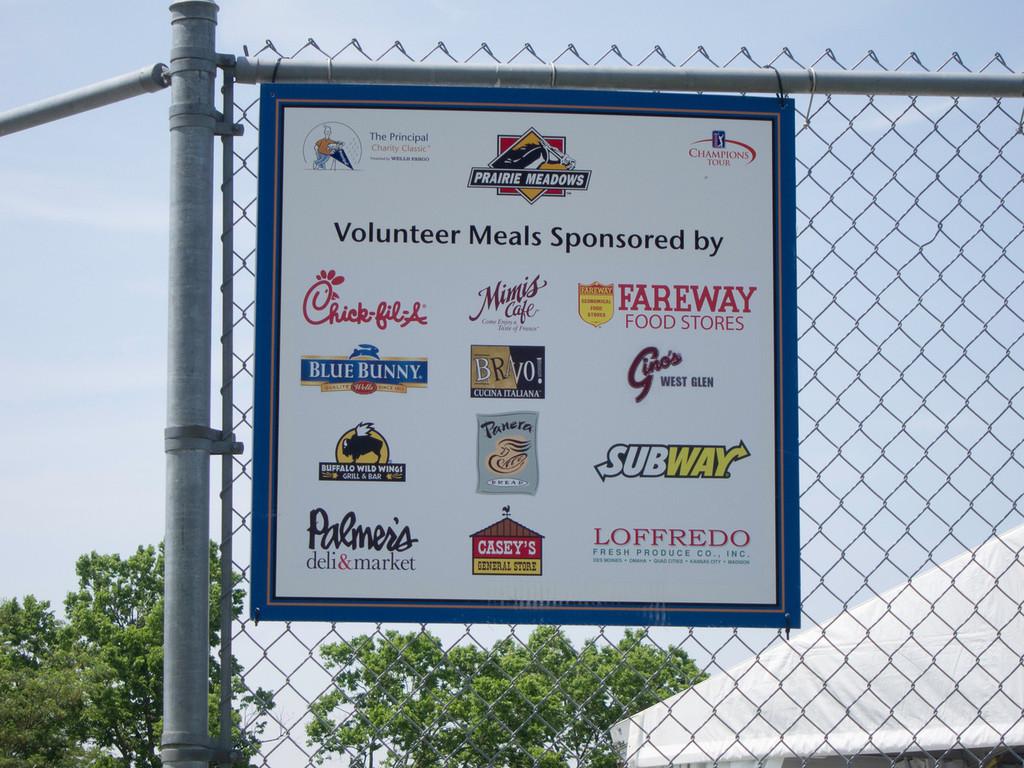What kind of meals are sponsored on this sign?
Your response must be concise. Fast food. 